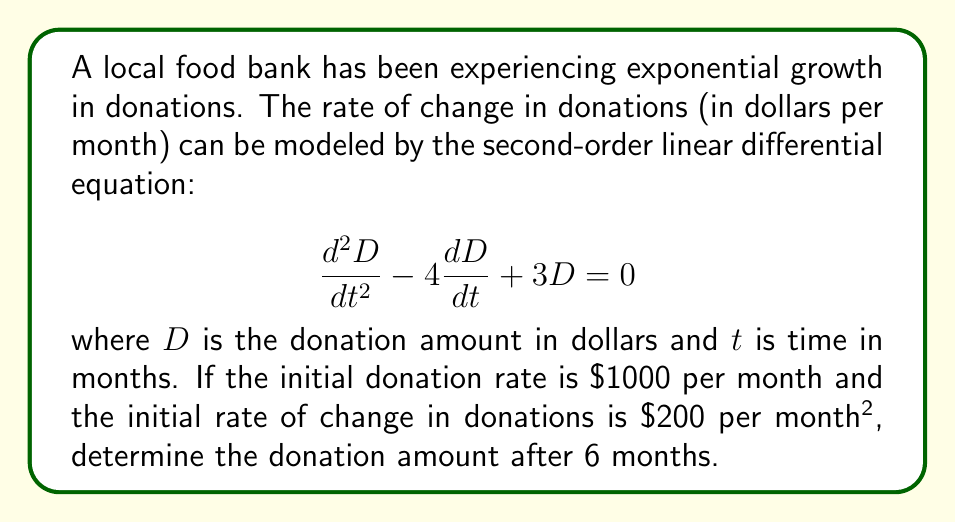Solve this math problem. To solve this problem, we need to follow these steps:

1) The general solution for this second-order linear differential equation is:

   $$D(t) = C_1e^{3t} + C_2e^t$$

2) We need to find $C_1$ and $C_2$ using the initial conditions:

   At $t=0$, $D(0) = 1000$ and $D'(0) = 200$

3) Using the first condition:

   $$1000 = C_1 + C_2$$

4) For the second condition, we differentiate $D(t)$:

   $$D'(t) = 3C_1e^{3t} + C_2e^t$$

   At $t=0$: $200 = 3C_1 + C_2$

5) Now we have a system of equations:

   $$C_1 + C_2 = 1000$$
   $$3C_1 + C_2 = 200$$

6) Subtracting the second equation from the first:

   $$-2C_1 = 800$$
   $$C_1 = -400$$

7) Substituting back into the first equation:

   $$-400 + C_2 = 1000$$
   $$C_2 = 1400$$

8) Our solution is therefore:

   $$D(t) = -400e^{3t} + 1400e^t$$

9) To find the donation amount after 6 months, we substitute $t=6$:

   $$D(6) = -400e^{18} + 1400e^6$$

10) Calculating this value:

    $$D(6) = -400(65659969.13) + 1400(403.42868) = -25,708,424,092$$
Answer: The donation amount after 6 months is approximately $\$25,708,424,092$. 